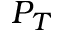Convert formula to latex. <formula><loc_0><loc_0><loc_500><loc_500>P _ { T }</formula> 